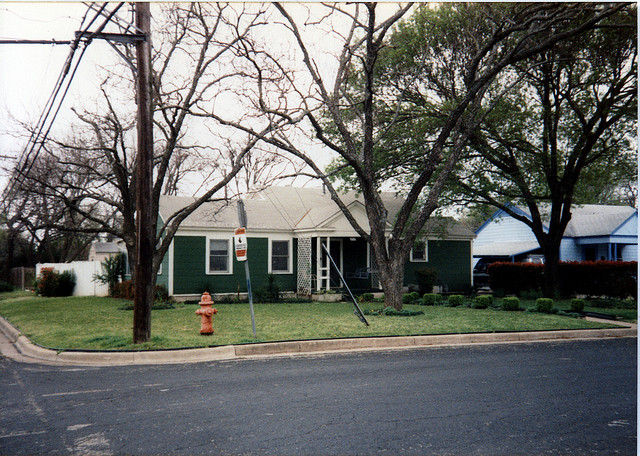Can you describe the season or weather based on the image? The image depicts a cloudy day and leafless trees, which could indicate that it is either late autumn or winter. The absence of snow or individuals in heavy coats suggests it may not be particularly cold, thus late autumn seems more plausible. 